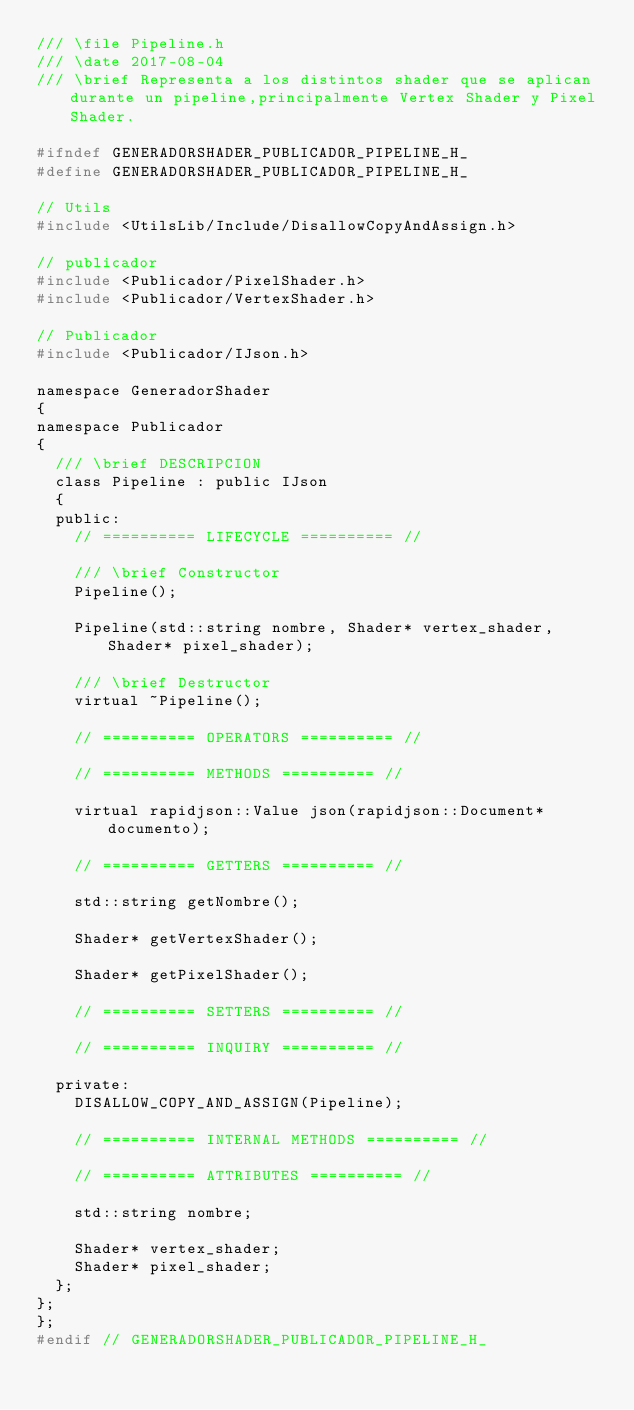<code> <loc_0><loc_0><loc_500><loc_500><_C_>/// \file Pipeline.h
/// \date 2017-08-04
/// \brief Representa a los distintos shader que se aplican durante un pipeline,principalmente Vertex Shader y Pixel Shader.

#ifndef GENERADORSHADER_PUBLICADOR_PIPELINE_H_
#define GENERADORSHADER_PUBLICADOR_PIPELINE_H_

// Utils
#include <UtilsLib/Include/DisallowCopyAndAssign.h>

// publicador
#include <Publicador/PixelShader.h>
#include <Publicador/VertexShader.h>

// Publicador
#include <Publicador/IJson.h>

namespace GeneradorShader
{
namespace Publicador
{
	/// \brief DESCRIPCION
	class Pipeline : public IJson
	{
	public:
		// ========== LIFECYCLE ========== //

		/// \brief Constructor
		Pipeline();

		Pipeline(std::string nombre, Shader* vertex_shader, Shader* pixel_shader);

		/// \brief Destructor
		virtual ~Pipeline();

		// ========== OPERATORS ========== //

		// ========== METHODS ========== //

		virtual rapidjson::Value json(rapidjson::Document* documento);

		// ========== GETTERS ========== //

		std::string getNombre();

		Shader* getVertexShader();

		Shader* getPixelShader();

		// ========== SETTERS ========== //

		// ========== INQUIRY ========== //

	private:
		DISALLOW_COPY_AND_ASSIGN(Pipeline);

		// ========== INTERNAL METHODS ========== //

		// ========== ATTRIBUTES ========== //

		std::string nombre;

		Shader* vertex_shader;
		Shader* pixel_shader;
	};
};
};
#endif // GENERADORSHADER_PUBLICADOR_PIPELINE_H_
</code> 